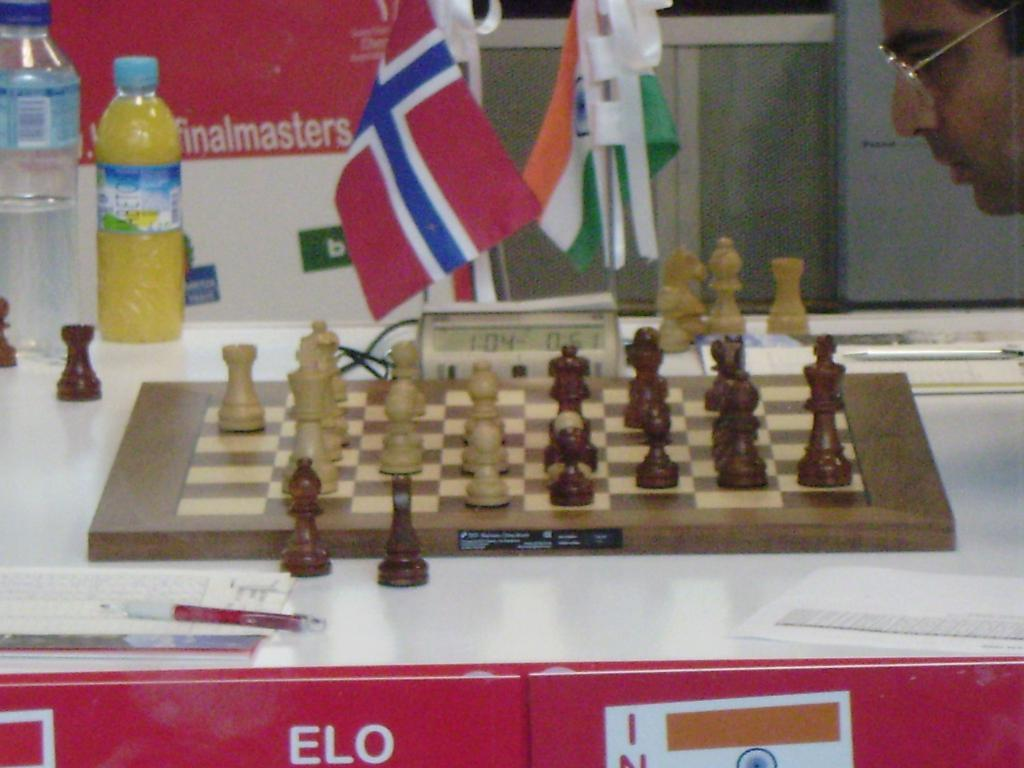<image>
Give a short and clear explanation of the subsequent image. A competitive chess game is being played on top of a table with the word ELO on it. 